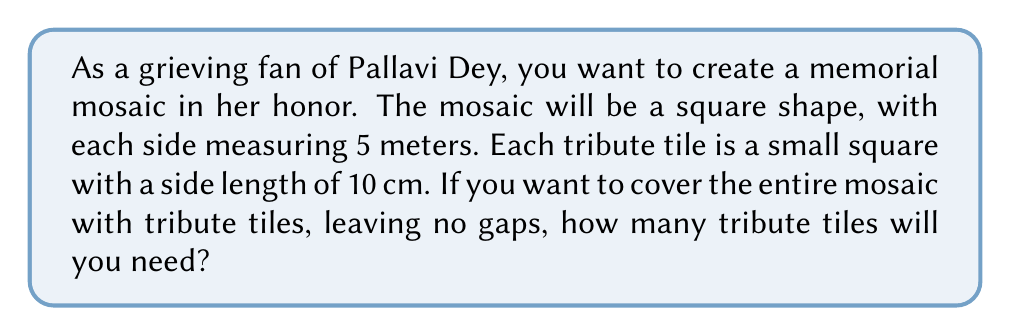Can you solve this math problem? Let's approach this problem step by step:

1. First, we need to convert the mosaic dimensions to centimeters:
   $5 \text{ meters} = 500 \text{ cm}$

2. Now we have a square mosaic with sides of 500 cm, and each tribute tile is 10 cm × 10 cm.

3. To find the number of tiles needed for one side of the mosaic:
   $$\text{Tiles per side} = \frac{\text{Length of mosaic side}}{\text{Length of tile side}} = \frac{500 \text{ cm}}{10 \text{ cm}} = 50 \text{ tiles}$$

4. Since the mosaic is a square, we need 50 tiles for each side.

5. To find the total number of tiles, we multiply the number of tiles on one side by itself:
   $$\text{Total tiles} = 50 \times 50 = 2500 \text{ tiles}$$

Therefore, you will need 2500 tribute tiles to create the memorial mosaic for Pallavi Dey.
Answer: 2500 tribute tiles 